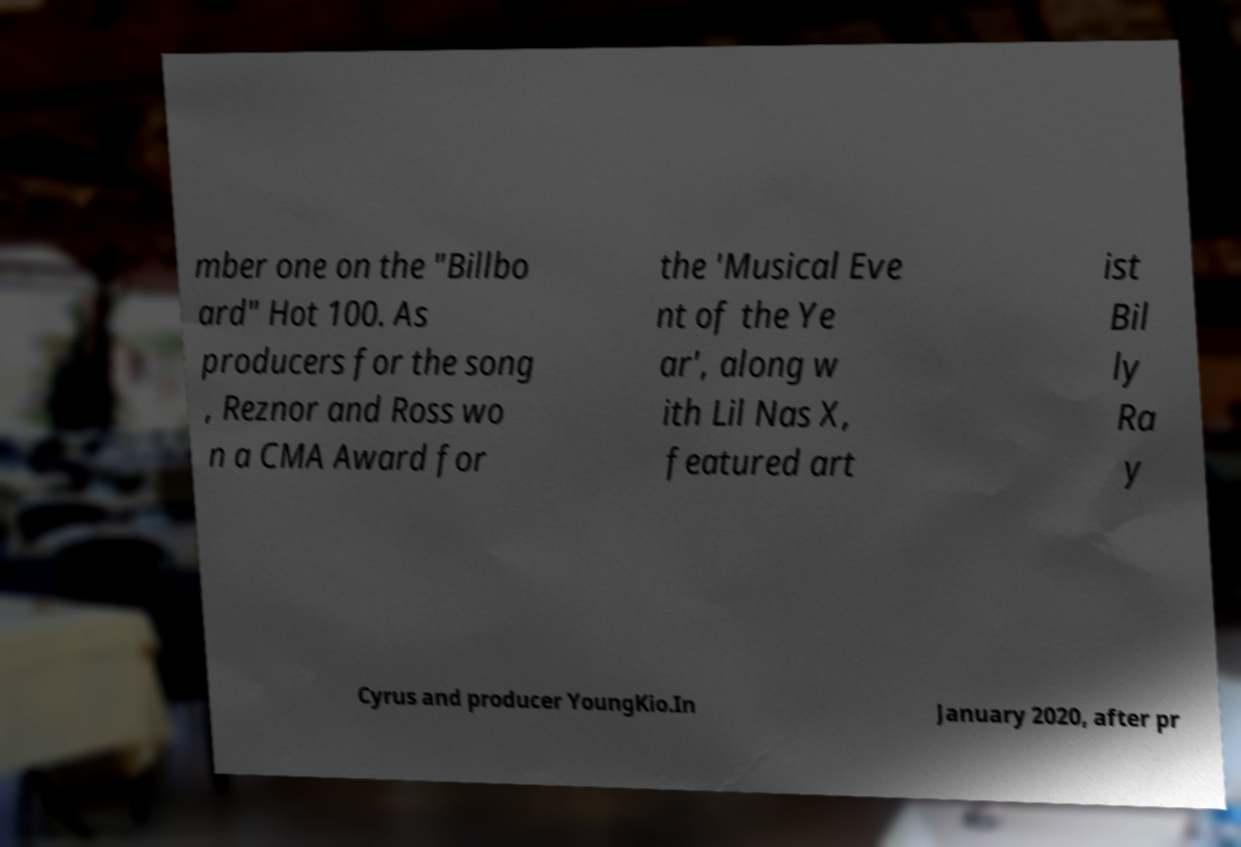Please identify and transcribe the text found in this image. mber one on the "Billbo ard" Hot 100. As producers for the song , Reznor and Ross wo n a CMA Award for the 'Musical Eve nt of the Ye ar', along w ith Lil Nas X, featured art ist Bil ly Ra y Cyrus and producer YoungKio.In January 2020, after pr 